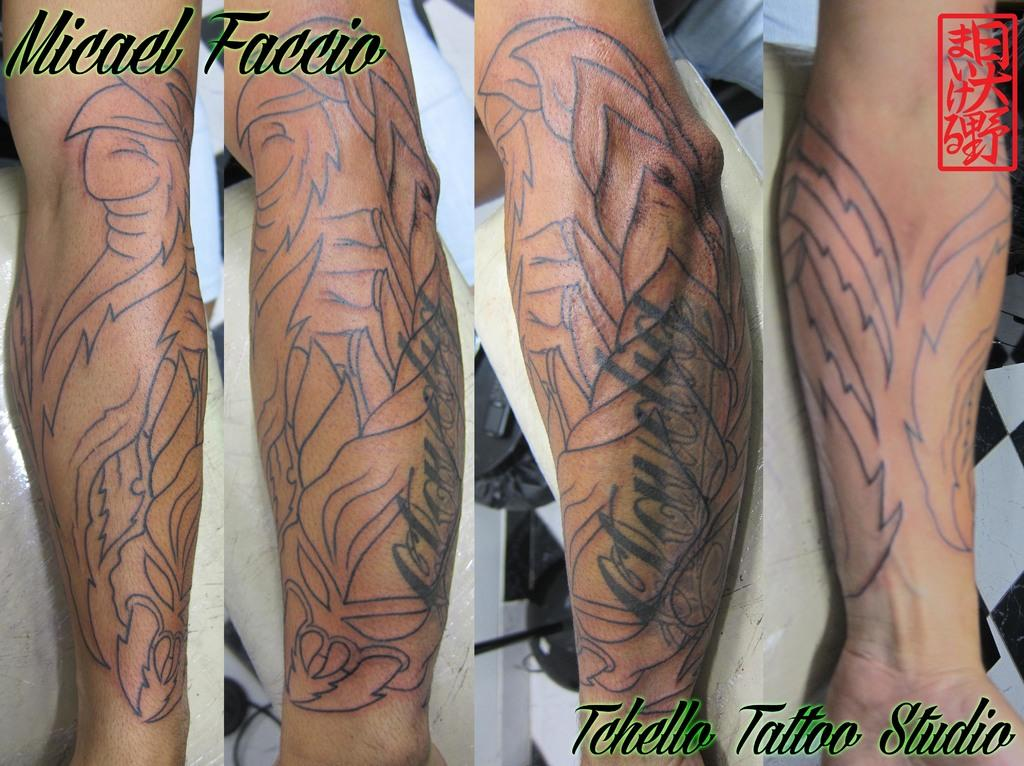What type of picture is in the image? There is a collage picture in the image. What can be seen on the hands in the image? There are four hands with tattoos in the image. Is there any text present in the image? Yes, there is text written on the image. What type of flame can be seen in the image? There is no flame present in the image. How many people are in the group in the image? There is no group of people present in the image; it only features a collage picture, hands with tattoos, and text. 